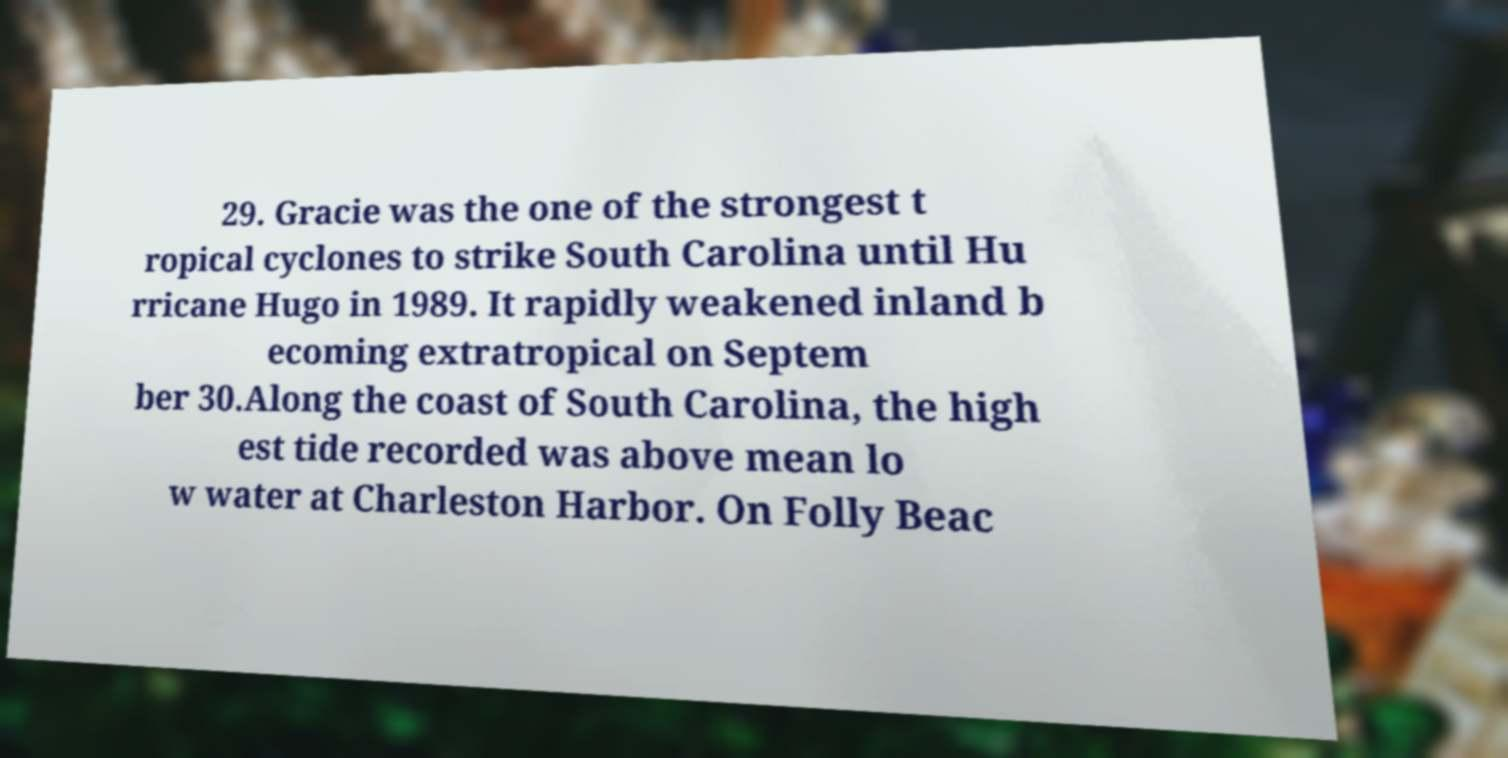For documentation purposes, I need the text within this image transcribed. Could you provide that? 29. Gracie was the one of the strongest t ropical cyclones to strike South Carolina until Hu rricane Hugo in 1989. It rapidly weakened inland b ecoming extratropical on Septem ber 30.Along the coast of South Carolina, the high est tide recorded was above mean lo w water at Charleston Harbor. On Folly Beac 